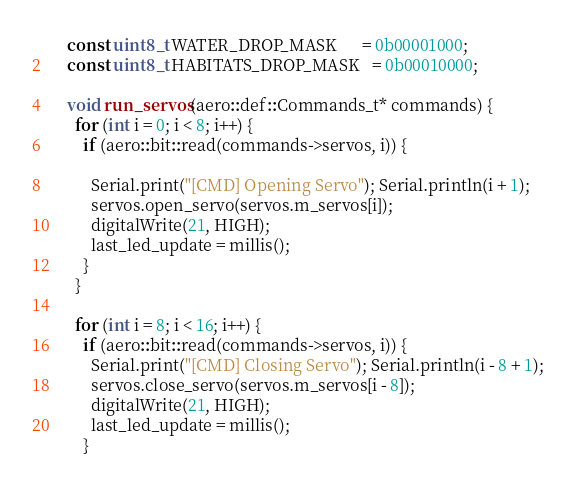Convert code to text. <code><loc_0><loc_0><loc_500><loc_500><_C++_>    const uint8_t WATER_DROP_MASK      = 0b00001000;
    const uint8_t HABITATS_DROP_MASK   = 0b00010000;

    void run_servos(aero::def::Commands_t* commands) {
      for (int i = 0; i < 8; i++) {
        if (aero::bit::read(commands->servos, i)) {
        
          Serial.print("[CMD] Opening Servo"); Serial.println(i + 1);
          servos.open_servo(servos.m_servos[i]);
          digitalWrite(21, HIGH);
          last_led_update = millis();
        }
      }

      for (int i = 8; i < 16; i++) {
        if (aero::bit::read(commands->servos, i)) {
          Serial.print("[CMD] Closing Servo"); Serial.println(i - 8 + 1);
          servos.close_servo(servos.m_servos[i - 8]);
          digitalWrite(21, HIGH);
          last_led_update = millis();
        }</code> 